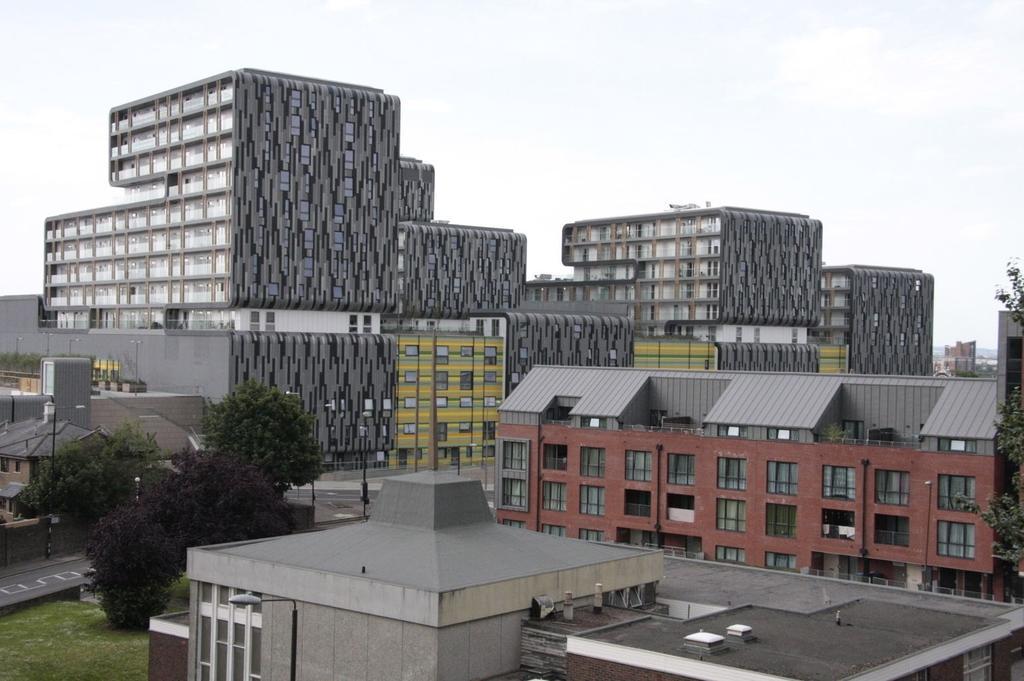Please provide a concise description of this image. In this image, we can see there are buildings, trees, poles, roads and grass on the ground. In the background, there are clouds in the sky. 